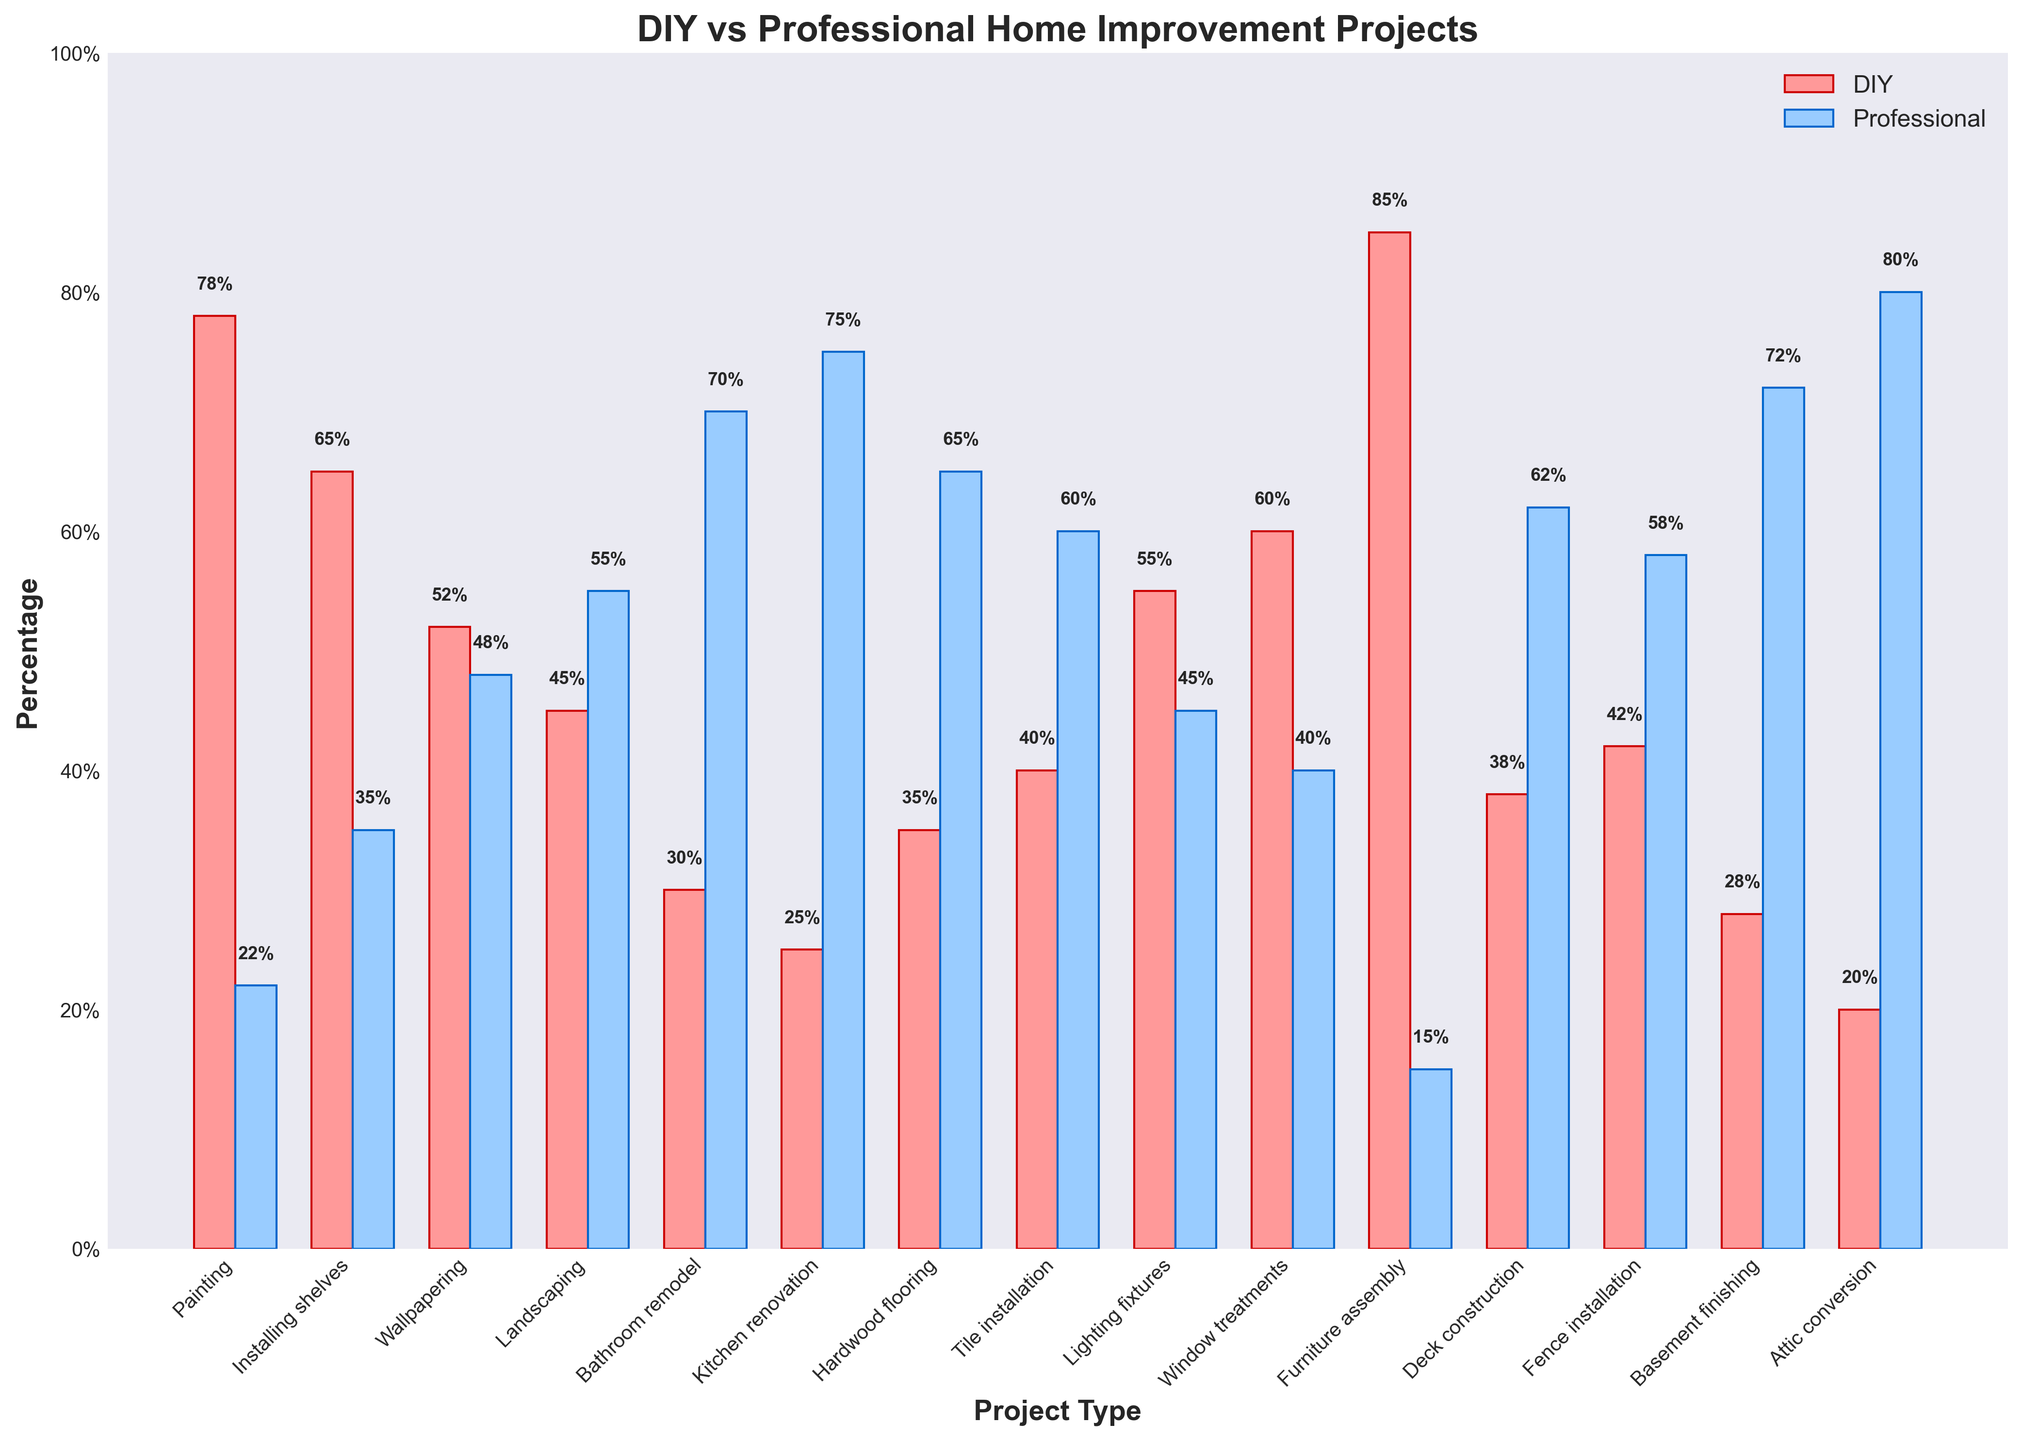Which project type has the highest percentage of DIY participation? The "Furniture assembly" project type has the highest bar for DIY with 85%.
Answer: Furniture assembly Which project type has the highest percentage of professional involvement? The "Attic conversion" project type shows the highest bar for professional involvement at 80%.
Answer: Attic conversion How much higher is the percentage of DIY for painting compared to bathroom remodel? The DIY percentage for painting is 78% and for bathroom remodel it is 30%. The difference is 78% - 30% = 48%.
Answer: 48% In which project types is professional involvement greater than DIY involvement? By comparing bar heights, professional involvement is greater in landscaping, bathroom remodel, kitchen renovation, hardwood flooring, tile installation, deck construction, fence installation, basement finishing, and attic conversion.
Answer: Landscaping, bathroom remodel, kitchen renovation, hardwood flooring, tile installation, deck construction, fence installation, basement finishing, attic conversion What is the average percentage of DIY participation across all project types? Sum all the DIY percentages and divide by the number of project types: (78+65+52+45+30+25+35+40+55+60+85+38+42+28+20)/15 = 47%.
Answer: 47% Which has a larger difference between DIY and professional involvement: lighting fixtures or tile installation? For lighting fixtures, DIY is 55% and professional is 45%, so the difference is 10%. For tile installation, DIY is 40% and professional is 60%, so the difference is 20%. Tile installation has the larger difference.
Answer: Tile installation Is there a project where DIY and professional involvement percentages are almost equal? The project "Wallpapering" has the closest percentages with DIY at 52% and professional at 48%, making them almost equal.
Answer: Wallpapering How does the percentage of DIY for attic conversion compare to kitchen renovation? The DIY percentage for attic conversion is 20%, and for kitchen renovation, it is 25%. Kitchen renovation has a higher DIY percentage.
Answer: Kitchen renovation has a higher DIY percentage What is the total percentage of professional involvement in deck construction, fence installation, and basement finishing combined? Sum the professional percentages for these three projects: Deck construction (62%) + Fence installation (58%) + Basement finishing (72%) = 192%.
Answer: 192% What is the difference in DIY percentage between installing shelves and window treatments? The DIY percentage for installing shelves is 65%, and for window treatments, it is 60%. The difference is 65% - 60% = 5%.
Answer: 5% 